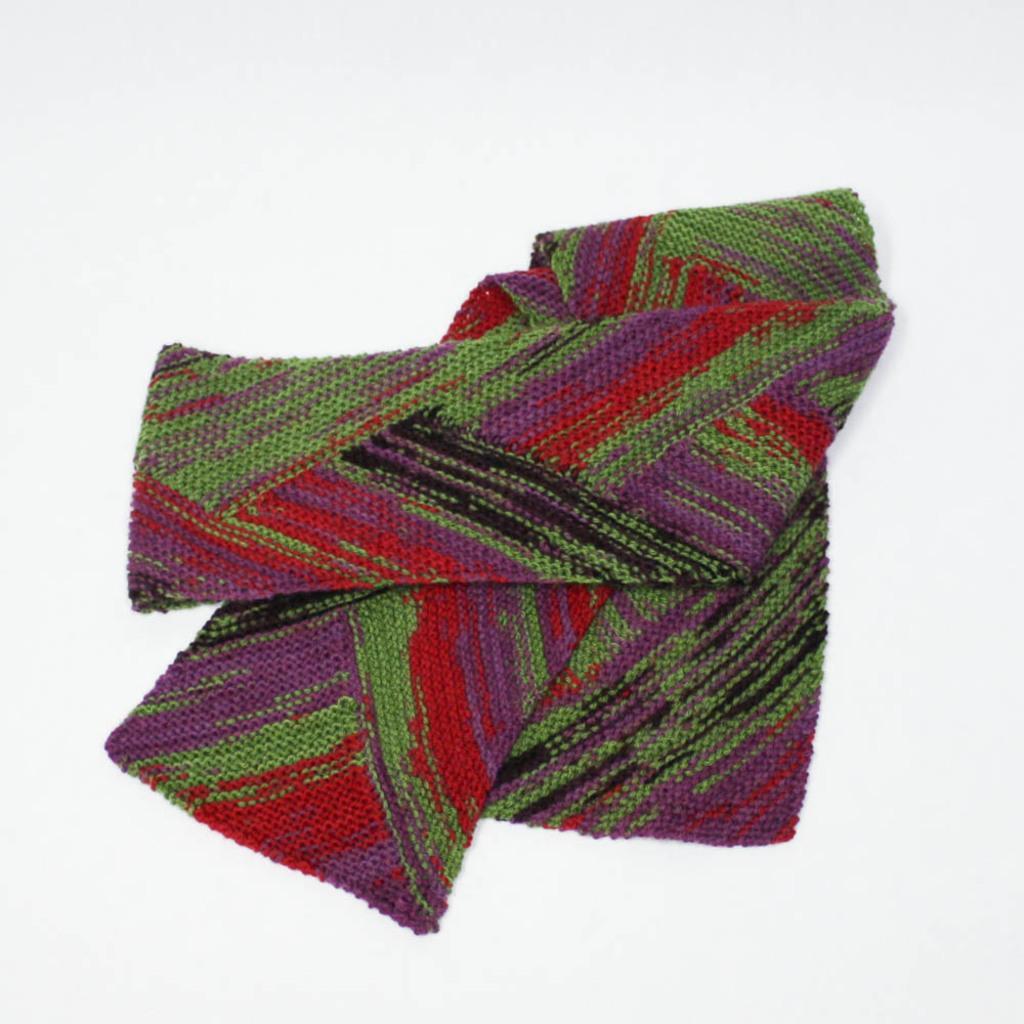Please provide a concise description of this image. In the middle of this image, there is a cloth in red, violet, green and black color combination, on a surface. And the background is white in color. 